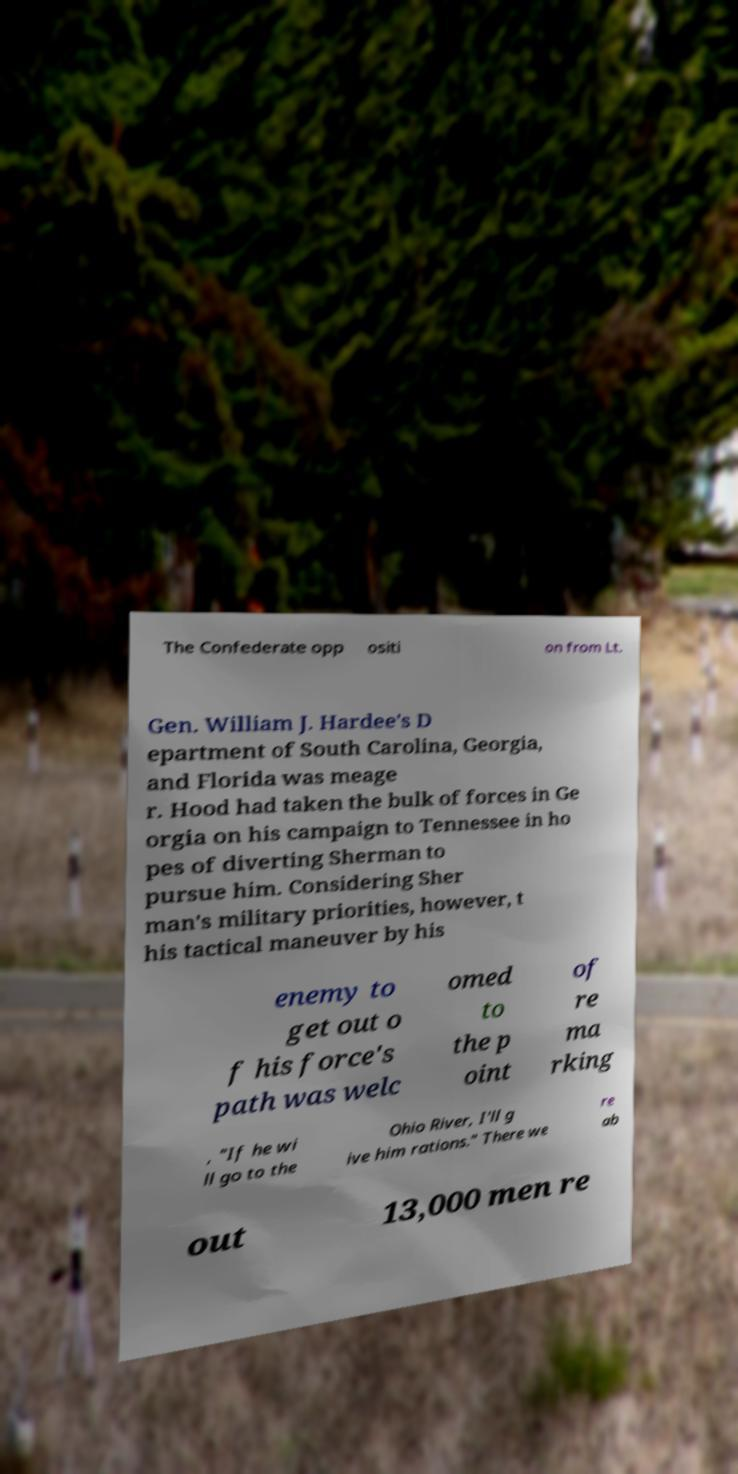Can you read and provide the text displayed in the image?This photo seems to have some interesting text. Can you extract and type it out for me? The Confederate opp ositi on from Lt. Gen. William J. Hardee's D epartment of South Carolina, Georgia, and Florida was meage r. Hood had taken the bulk of forces in Ge orgia on his campaign to Tennessee in ho pes of diverting Sherman to pursue him. Considering Sher man's military priorities, however, t his tactical maneuver by his enemy to get out o f his force's path was welc omed to the p oint of re ma rking , "If he wi ll go to the Ohio River, I'll g ive him rations." There we re ab out 13,000 men re 